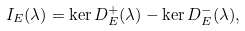Convert formula to latex. <formula><loc_0><loc_0><loc_500><loc_500>I _ { E } ( \lambda ) = \ker D _ { E } ^ { + } ( \lambda ) - \ker D _ { E } ^ { - } ( \lambda ) ,</formula> 